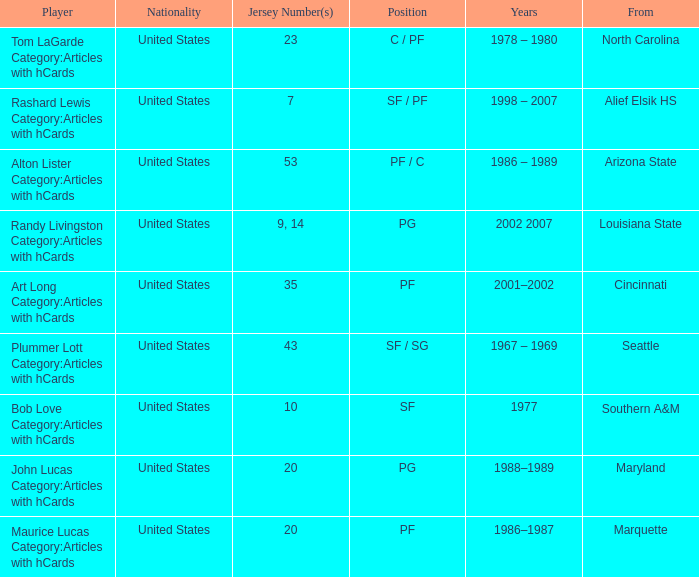In the alton lister category: articles with hcards, what are the years mentioned? 1986 – 1989. 